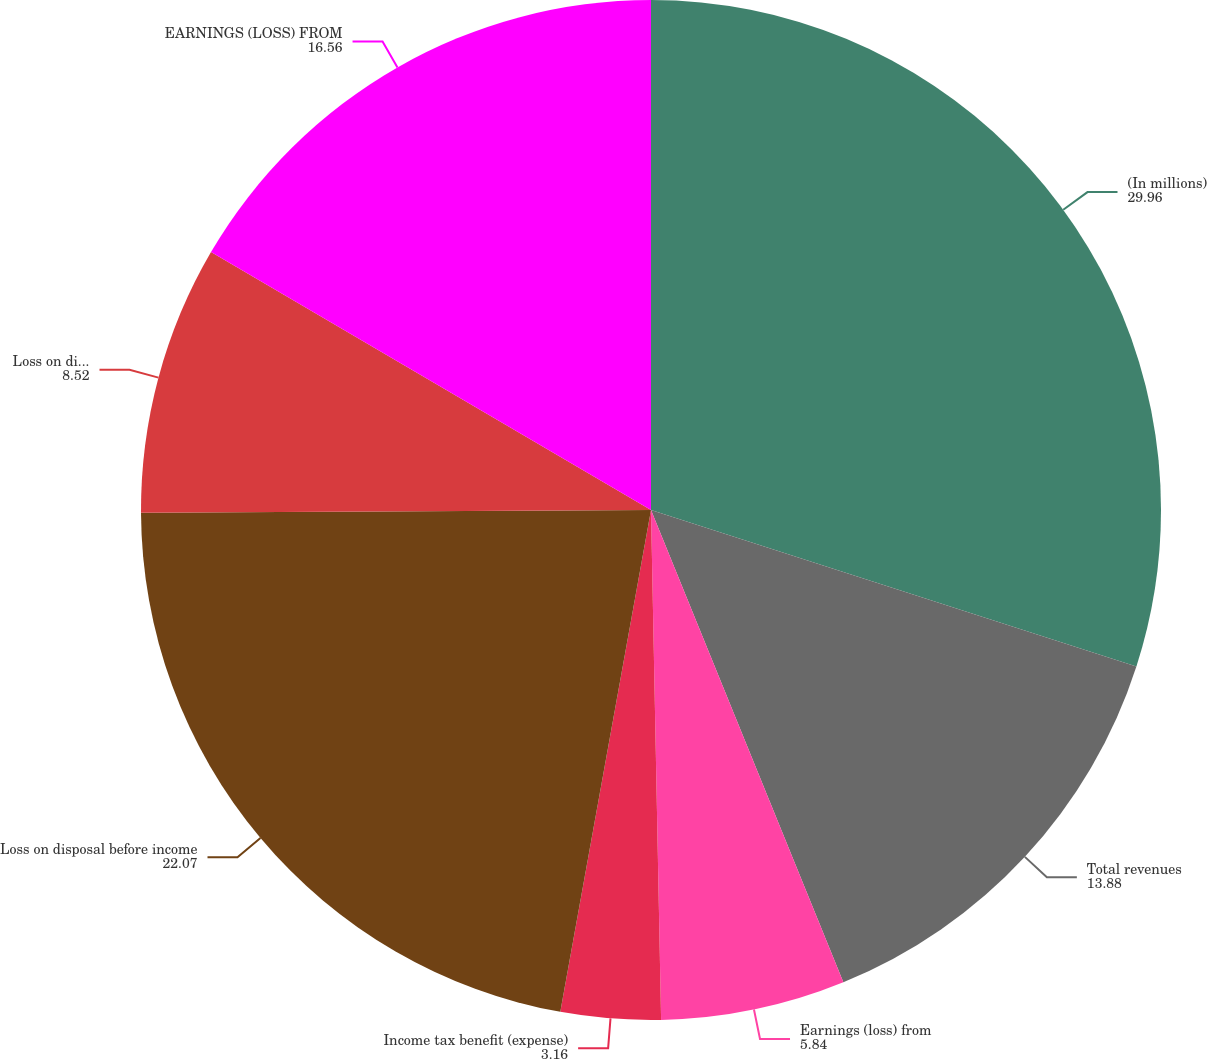<chart> <loc_0><loc_0><loc_500><loc_500><pie_chart><fcel>(In millions)<fcel>Total revenues<fcel>Earnings (loss) from<fcel>Income tax benefit (expense)<fcel>Loss on disposal before income<fcel>Loss on disposal net of taxes<fcel>EARNINGS (LOSS) FROM<nl><fcel>29.96%<fcel>13.88%<fcel>5.84%<fcel>3.16%<fcel>22.07%<fcel>8.52%<fcel>16.56%<nl></chart> 